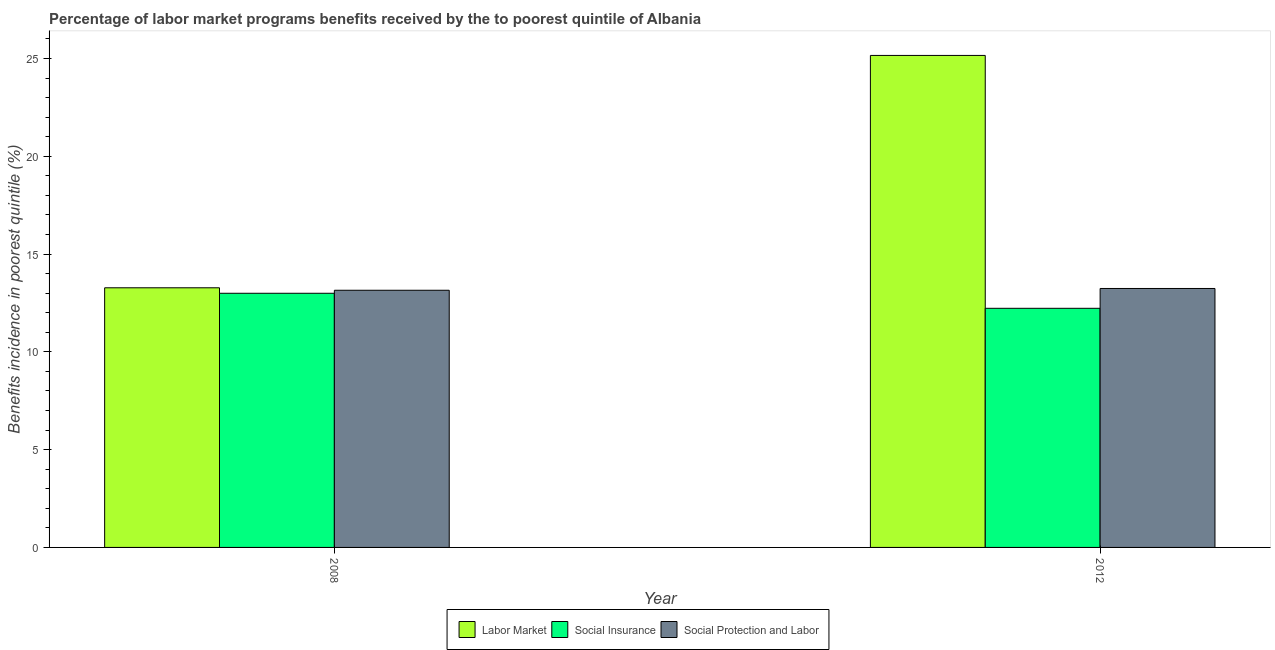Are the number of bars per tick equal to the number of legend labels?
Keep it short and to the point. Yes. Are the number of bars on each tick of the X-axis equal?
Provide a succinct answer. Yes. What is the label of the 2nd group of bars from the left?
Provide a succinct answer. 2012. What is the percentage of benefits received due to social insurance programs in 2008?
Offer a very short reply. 13. Across all years, what is the maximum percentage of benefits received due to social protection programs?
Your answer should be compact. 13.24. Across all years, what is the minimum percentage of benefits received due to social protection programs?
Offer a very short reply. 13.15. In which year was the percentage of benefits received due to social protection programs maximum?
Make the answer very short. 2012. What is the total percentage of benefits received due to social insurance programs in the graph?
Your answer should be very brief. 25.22. What is the difference between the percentage of benefits received due to social insurance programs in 2008 and that in 2012?
Make the answer very short. 0.77. What is the difference between the percentage of benefits received due to social insurance programs in 2008 and the percentage of benefits received due to labor market programs in 2012?
Your answer should be very brief. 0.77. What is the average percentage of benefits received due to social insurance programs per year?
Your answer should be very brief. 12.61. In the year 2008, what is the difference between the percentage of benefits received due to social insurance programs and percentage of benefits received due to social protection programs?
Offer a terse response. 0. In how many years, is the percentage of benefits received due to social protection programs greater than 22 %?
Provide a short and direct response. 0. What is the ratio of the percentage of benefits received due to social protection programs in 2008 to that in 2012?
Provide a short and direct response. 0.99. Is the percentage of benefits received due to labor market programs in 2008 less than that in 2012?
Provide a short and direct response. Yes. What does the 3rd bar from the left in 2008 represents?
Give a very brief answer. Social Protection and Labor. What does the 2nd bar from the right in 2012 represents?
Your response must be concise. Social Insurance. How many bars are there?
Your answer should be very brief. 6. How are the legend labels stacked?
Provide a short and direct response. Horizontal. What is the title of the graph?
Provide a succinct answer. Percentage of labor market programs benefits received by the to poorest quintile of Albania. Does "Ages 65 and above" appear as one of the legend labels in the graph?
Your response must be concise. No. What is the label or title of the X-axis?
Make the answer very short. Year. What is the label or title of the Y-axis?
Give a very brief answer. Benefits incidence in poorest quintile (%). What is the Benefits incidence in poorest quintile (%) of Labor Market in 2008?
Provide a succinct answer. 13.28. What is the Benefits incidence in poorest quintile (%) of Social Insurance in 2008?
Your answer should be compact. 13. What is the Benefits incidence in poorest quintile (%) in Social Protection and Labor in 2008?
Provide a succinct answer. 13.15. What is the Benefits incidence in poorest quintile (%) of Labor Market in 2012?
Make the answer very short. 25.16. What is the Benefits incidence in poorest quintile (%) in Social Insurance in 2012?
Your response must be concise. 12.23. What is the Benefits incidence in poorest quintile (%) of Social Protection and Labor in 2012?
Provide a succinct answer. 13.24. Across all years, what is the maximum Benefits incidence in poorest quintile (%) of Labor Market?
Offer a very short reply. 25.16. Across all years, what is the maximum Benefits incidence in poorest quintile (%) of Social Insurance?
Offer a very short reply. 13. Across all years, what is the maximum Benefits incidence in poorest quintile (%) in Social Protection and Labor?
Provide a short and direct response. 13.24. Across all years, what is the minimum Benefits incidence in poorest quintile (%) of Labor Market?
Provide a short and direct response. 13.28. Across all years, what is the minimum Benefits incidence in poorest quintile (%) in Social Insurance?
Offer a very short reply. 12.23. Across all years, what is the minimum Benefits incidence in poorest quintile (%) in Social Protection and Labor?
Ensure brevity in your answer.  13.15. What is the total Benefits incidence in poorest quintile (%) in Labor Market in the graph?
Your response must be concise. 38.44. What is the total Benefits incidence in poorest quintile (%) of Social Insurance in the graph?
Offer a very short reply. 25.22. What is the total Benefits incidence in poorest quintile (%) in Social Protection and Labor in the graph?
Offer a very short reply. 26.39. What is the difference between the Benefits incidence in poorest quintile (%) of Labor Market in 2008 and that in 2012?
Make the answer very short. -11.88. What is the difference between the Benefits incidence in poorest quintile (%) of Social Insurance in 2008 and that in 2012?
Ensure brevity in your answer.  0.77. What is the difference between the Benefits incidence in poorest quintile (%) of Social Protection and Labor in 2008 and that in 2012?
Give a very brief answer. -0.09. What is the difference between the Benefits incidence in poorest quintile (%) of Labor Market in 2008 and the Benefits incidence in poorest quintile (%) of Social Insurance in 2012?
Offer a terse response. 1.05. What is the difference between the Benefits incidence in poorest quintile (%) of Labor Market in 2008 and the Benefits incidence in poorest quintile (%) of Social Protection and Labor in 2012?
Offer a terse response. 0.04. What is the difference between the Benefits incidence in poorest quintile (%) in Social Insurance in 2008 and the Benefits incidence in poorest quintile (%) in Social Protection and Labor in 2012?
Keep it short and to the point. -0.24. What is the average Benefits incidence in poorest quintile (%) in Labor Market per year?
Make the answer very short. 19.22. What is the average Benefits incidence in poorest quintile (%) of Social Insurance per year?
Your answer should be very brief. 12.61. What is the average Benefits incidence in poorest quintile (%) in Social Protection and Labor per year?
Provide a succinct answer. 13.2. In the year 2008, what is the difference between the Benefits incidence in poorest quintile (%) in Labor Market and Benefits incidence in poorest quintile (%) in Social Insurance?
Make the answer very short. 0.28. In the year 2008, what is the difference between the Benefits incidence in poorest quintile (%) in Labor Market and Benefits incidence in poorest quintile (%) in Social Protection and Labor?
Your response must be concise. 0.13. In the year 2008, what is the difference between the Benefits incidence in poorest quintile (%) in Social Insurance and Benefits incidence in poorest quintile (%) in Social Protection and Labor?
Provide a short and direct response. -0.15. In the year 2012, what is the difference between the Benefits incidence in poorest quintile (%) of Labor Market and Benefits incidence in poorest quintile (%) of Social Insurance?
Keep it short and to the point. 12.93. In the year 2012, what is the difference between the Benefits incidence in poorest quintile (%) of Labor Market and Benefits incidence in poorest quintile (%) of Social Protection and Labor?
Provide a succinct answer. 11.92. In the year 2012, what is the difference between the Benefits incidence in poorest quintile (%) in Social Insurance and Benefits incidence in poorest quintile (%) in Social Protection and Labor?
Give a very brief answer. -1.01. What is the ratio of the Benefits incidence in poorest quintile (%) in Labor Market in 2008 to that in 2012?
Make the answer very short. 0.53. What is the ratio of the Benefits incidence in poorest quintile (%) of Social Insurance in 2008 to that in 2012?
Give a very brief answer. 1.06. What is the ratio of the Benefits incidence in poorest quintile (%) in Social Protection and Labor in 2008 to that in 2012?
Your answer should be compact. 0.99. What is the difference between the highest and the second highest Benefits incidence in poorest quintile (%) of Labor Market?
Your response must be concise. 11.88. What is the difference between the highest and the second highest Benefits incidence in poorest quintile (%) of Social Insurance?
Your response must be concise. 0.77. What is the difference between the highest and the second highest Benefits incidence in poorest quintile (%) in Social Protection and Labor?
Keep it short and to the point. 0.09. What is the difference between the highest and the lowest Benefits incidence in poorest quintile (%) in Labor Market?
Your answer should be very brief. 11.88. What is the difference between the highest and the lowest Benefits incidence in poorest quintile (%) of Social Insurance?
Ensure brevity in your answer.  0.77. What is the difference between the highest and the lowest Benefits incidence in poorest quintile (%) in Social Protection and Labor?
Give a very brief answer. 0.09. 